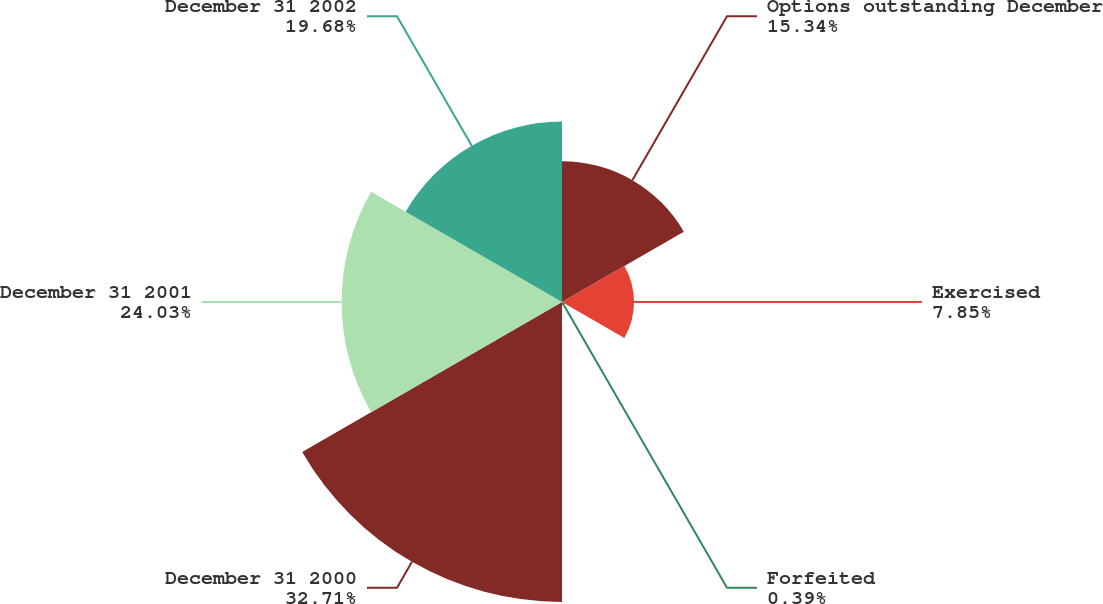Convert chart to OTSL. <chart><loc_0><loc_0><loc_500><loc_500><pie_chart><fcel>Options outstanding December<fcel>Exercised<fcel>Forfeited<fcel>December 31 2000<fcel>December 31 2001<fcel>December 31 2002<nl><fcel>15.34%<fcel>7.85%<fcel>0.39%<fcel>32.71%<fcel>24.03%<fcel>19.68%<nl></chart> 